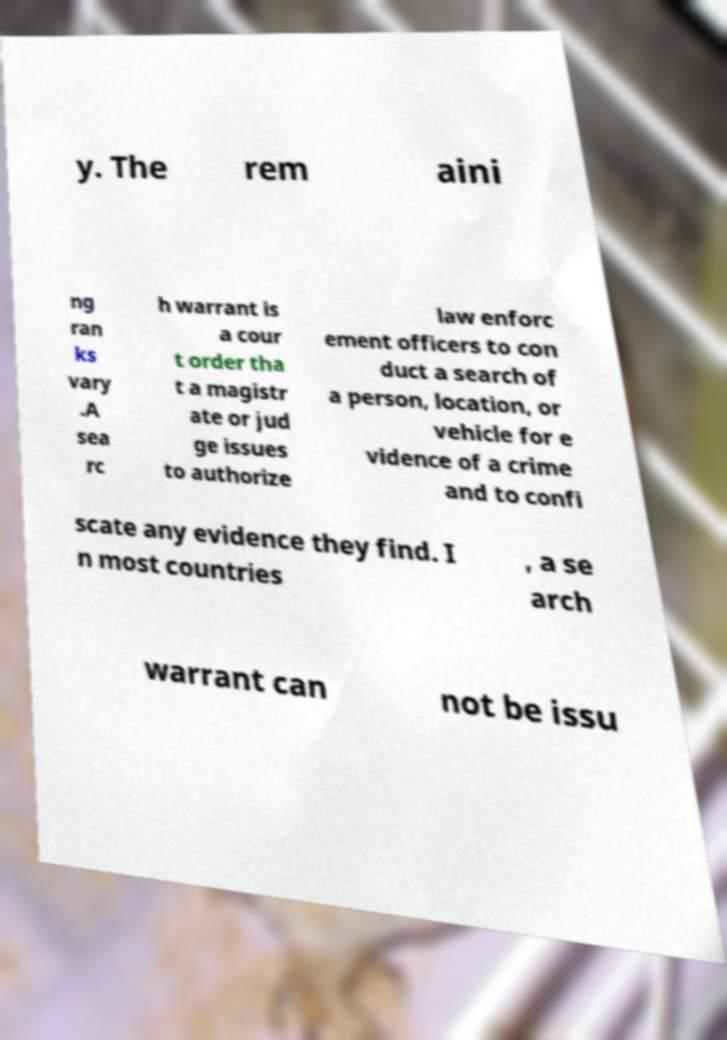Can you accurately transcribe the text from the provided image for me? y. The rem aini ng ran ks vary .A sea rc h warrant is a cour t order tha t a magistr ate or jud ge issues to authorize law enforc ement officers to con duct a search of a person, location, or vehicle for e vidence of a crime and to confi scate any evidence they find. I n most countries , a se arch warrant can not be issu 